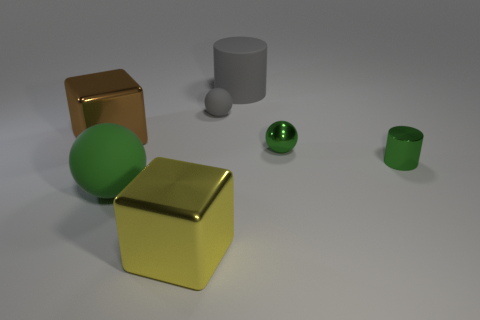Subtract all matte spheres. How many spheres are left? 1 Subtract all brown cylinders. How many green balls are left? 2 Subtract 1 balls. How many balls are left? 2 Add 1 large gray objects. How many objects exist? 8 Subtract all blocks. How many objects are left? 5 Add 5 big green matte things. How many big green matte things are left? 6 Add 3 tiny cyan things. How many tiny cyan things exist? 3 Subtract 0 green cubes. How many objects are left? 7 Subtract all blue balls. Subtract all brown blocks. How many balls are left? 3 Subtract all matte objects. Subtract all small cyan rubber things. How many objects are left? 4 